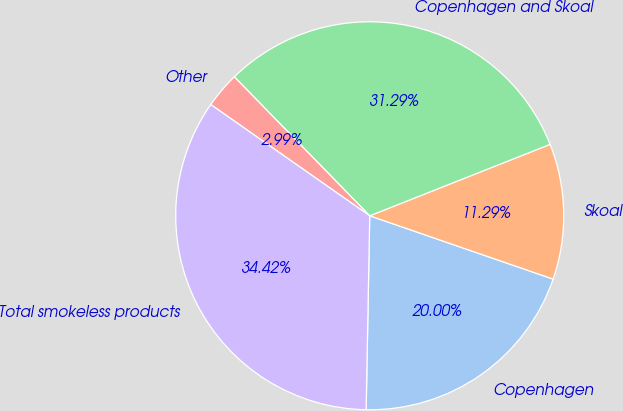<chart> <loc_0><loc_0><loc_500><loc_500><pie_chart><fcel>Copenhagen<fcel>Skoal<fcel>Copenhagen and Skoal<fcel>Other<fcel>Total smokeless products<nl><fcel>20.0%<fcel>11.29%<fcel>31.29%<fcel>2.99%<fcel>34.42%<nl></chart> 